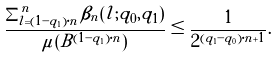Convert formula to latex. <formula><loc_0><loc_0><loc_500><loc_500>\frac { \sum _ { l = ( 1 - q _ { 1 } ) \cdot n } ^ { n } \beta _ { n } ( l ; q _ { 0 } , q _ { 1 } ) } { \mu ( B ^ { ( 1 - q _ { 1 } ) \cdot n } ) } \leq \frac { 1 } { 2 ^ { ( q _ { 1 } - q _ { 0 } ) \cdot n + 1 } } .</formula> 